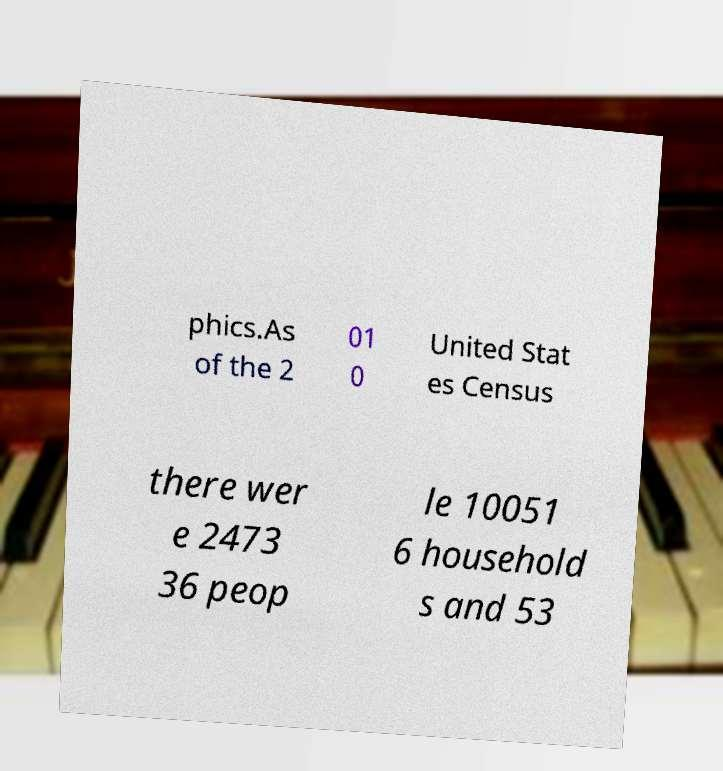For documentation purposes, I need the text within this image transcribed. Could you provide that? phics.As of the 2 01 0 United Stat es Census there wer e 2473 36 peop le 10051 6 household s and 53 